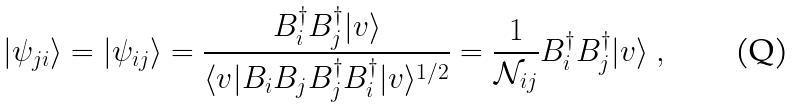Convert formula to latex. <formula><loc_0><loc_0><loc_500><loc_500>| \psi _ { j i } \rangle = | \psi _ { i j } \rangle = \frac { B _ { i } ^ { \dag } B _ { j } ^ { \dag } | v \rangle } { \langle v | B _ { i } B _ { j } B _ { j } ^ { \dag } B _ { i } ^ { \dag } | v \rangle ^ { 1 / 2 } } = \frac { 1 } { \mathcal { N } _ { i j } } B _ { i } ^ { \dag } B _ { j } ^ { \dag } | v \rangle \ ,</formula> 